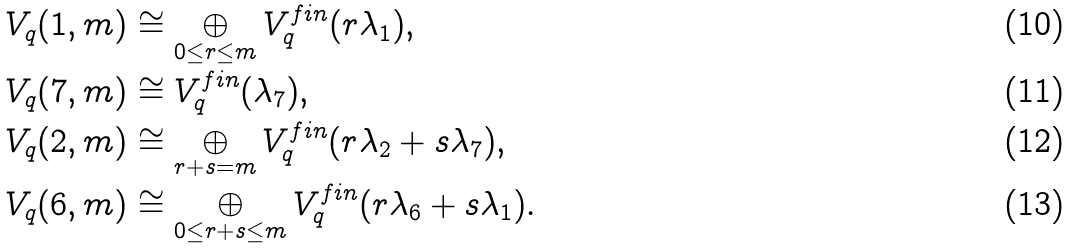Convert formula to latex. <formula><loc_0><loc_0><loc_500><loc_500>V _ { q } ( 1 , m ) & \cong \bigoplus _ { 0 \leq r \leq m } V _ { q } ^ { f i n } ( r \lambda _ { 1 } ) , \\ V _ { q } ( 7 , m ) & \cong V _ { q } ^ { f i n } ( \lambda _ { 7 } ) , \\ V _ { q } ( 2 , m ) & \cong \bigoplus _ { r + s = m } V _ { q } ^ { f i n } ( r \lambda _ { 2 } + s \lambda _ { 7 } ) , \\ V _ { q } ( 6 , m ) & \cong \bigoplus _ { 0 \leq r + s \leq m } V _ { q } ^ { f i n } ( r \lambda _ { 6 } + s \lambda _ { 1 } ) .</formula> 